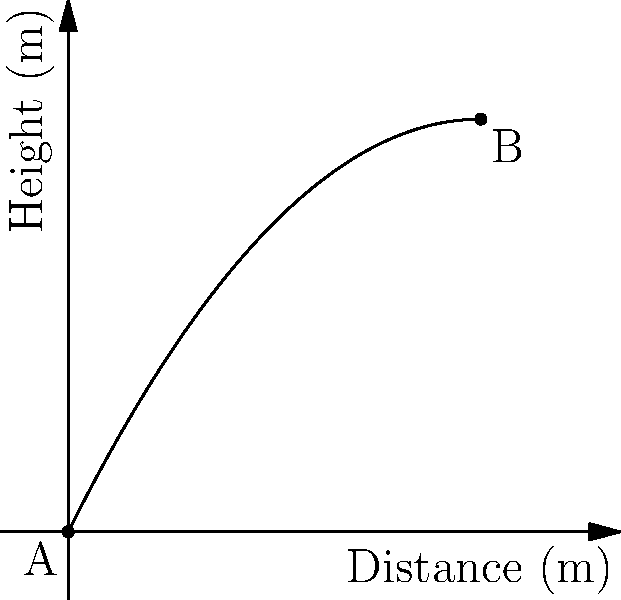In a study on airborne transmission of viruses, a particle's trajectory is modeled by the equation $h(x) = -0.1x^2 + 2x$, where $h$ is the height in meters and $x$ is the horizontal distance in meters. If the particle travels from point A (0,0) to point B (10,h(10)), what is the maximum height reached by the particle? Relate this to the importance of understanding particle dynamics in public health interventions. To find the maximum height of the particle's trajectory, we need to follow these steps:

1) The function describing the trajectory is $h(x) = -0.1x^2 + 2x$.

2) To find the maximum point, we need to find where the derivative of this function equals zero:
   $h'(x) = -0.2x + 2$
   Set this equal to zero: $-0.2x + 2 = 0$

3) Solve for x:
   $-0.2x = -2$
   $x = 10$

4) This x-value represents the horizontal distance at which the maximum height occurs.

5) To find the maximum height, plug this x-value back into the original equation:
   $h(10) = -0.1(10)^2 + 2(10)$
   $= -10 + 20$
   $= 10$ meters

6) Therefore, the maximum height reached by the particle is 10 meters.

In public health, understanding the dynamics of airborne particles is crucial for developing effective interventions to prevent the spread of respiratory diseases. This model demonstrates how far and high a virus particle might travel, informing decisions on social distancing measures, ventilation requirements, and the design of personal protective equipment.
Answer: 10 meters 